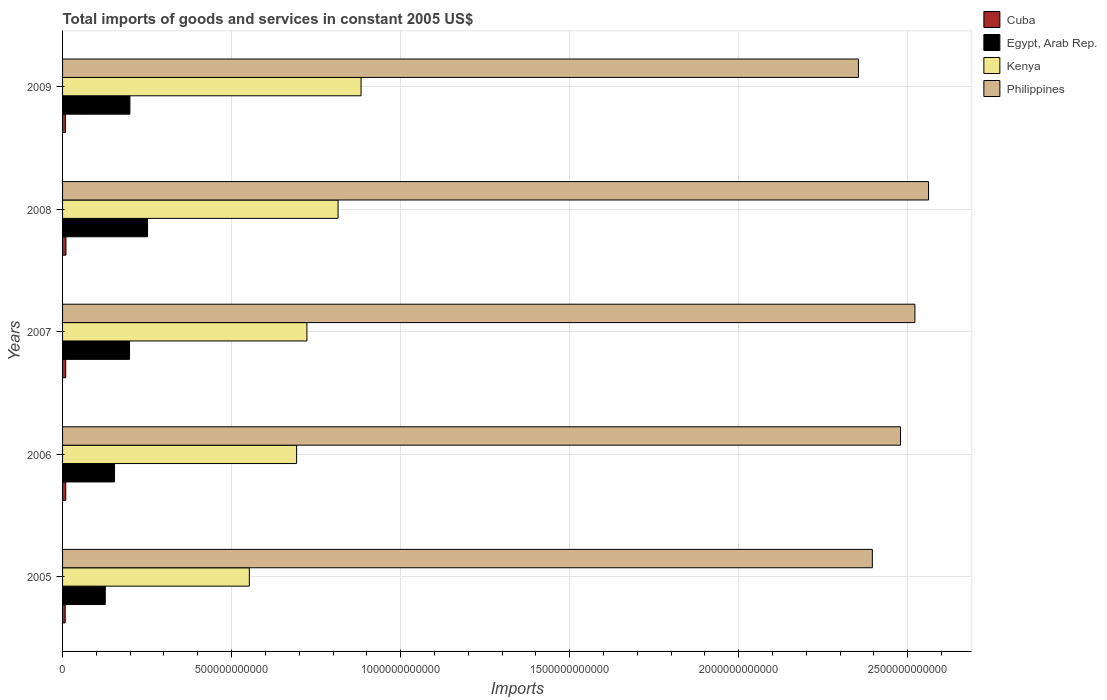How many groups of bars are there?
Keep it short and to the point. 5. Are the number of bars per tick equal to the number of legend labels?
Offer a terse response. Yes. How many bars are there on the 4th tick from the top?
Give a very brief answer. 4. What is the total imports of goods and services in Kenya in 2008?
Keep it short and to the point. 8.15e+11. Across all years, what is the maximum total imports of goods and services in Cuba?
Provide a succinct answer. 1.00e+1. Across all years, what is the minimum total imports of goods and services in Egypt, Arab Rep.?
Your answer should be compact. 1.26e+11. In which year was the total imports of goods and services in Philippines maximum?
Make the answer very short. 2008. In which year was the total imports of goods and services in Cuba minimum?
Provide a short and direct response. 2005. What is the total total imports of goods and services in Philippines in the graph?
Your answer should be compact. 1.23e+13. What is the difference between the total imports of goods and services in Kenya in 2005 and that in 2007?
Offer a very short reply. -1.70e+11. What is the difference between the total imports of goods and services in Kenya in 2009 and the total imports of goods and services in Egypt, Arab Rep. in 2008?
Provide a succinct answer. 6.32e+11. What is the average total imports of goods and services in Kenya per year?
Your answer should be compact. 7.33e+11. In the year 2005, what is the difference between the total imports of goods and services in Egypt, Arab Rep. and total imports of goods and services in Kenya?
Keep it short and to the point. -4.26e+11. What is the ratio of the total imports of goods and services in Kenya in 2008 to that in 2009?
Give a very brief answer. 0.92. Is the difference between the total imports of goods and services in Egypt, Arab Rep. in 2006 and 2008 greater than the difference between the total imports of goods and services in Kenya in 2006 and 2008?
Keep it short and to the point. Yes. What is the difference between the highest and the second highest total imports of goods and services in Cuba?
Offer a very short reply. 5.83e+08. What is the difference between the highest and the lowest total imports of goods and services in Cuba?
Your answer should be very brief. 2.18e+09. What does the 3rd bar from the top in 2007 represents?
Keep it short and to the point. Egypt, Arab Rep. What does the 2nd bar from the bottom in 2009 represents?
Offer a terse response. Egypt, Arab Rep. Is it the case that in every year, the sum of the total imports of goods and services in Philippines and total imports of goods and services in Egypt, Arab Rep. is greater than the total imports of goods and services in Kenya?
Offer a very short reply. Yes. What is the difference between two consecutive major ticks on the X-axis?
Provide a short and direct response. 5.00e+11. Does the graph contain any zero values?
Provide a succinct answer. No. Does the graph contain grids?
Your answer should be compact. Yes. Where does the legend appear in the graph?
Give a very brief answer. Top right. How are the legend labels stacked?
Your response must be concise. Vertical. What is the title of the graph?
Give a very brief answer. Total imports of goods and services in constant 2005 US$. What is the label or title of the X-axis?
Offer a terse response. Imports. What is the label or title of the Y-axis?
Offer a terse response. Years. What is the Imports in Cuba in 2005?
Your response must be concise. 7.82e+09. What is the Imports of Egypt, Arab Rep. in 2005?
Make the answer very short. 1.26e+11. What is the Imports in Kenya in 2005?
Keep it short and to the point. 5.52e+11. What is the Imports of Philippines in 2005?
Make the answer very short. 2.40e+12. What is the Imports of Cuba in 2006?
Provide a short and direct response. 9.42e+09. What is the Imports of Egypt, Arab Rep. in 2006?
Offer a very short reply. 1.54e+11. What is the Imports of Kenya in 2006?
Give a very brief answer. 6.92e+11. What is the Imports in Philippines in 2006?
Provide a succinct answer. 2.48e+12. What is the Imports in Cuba in 2007?
Your answer should be compact. 9.32e+09. What is the Imports in Egypt, Arab Rep. in 2007?
Provide a short and direct response. 1.98e+11. What is the Imports of Kenya in 2007?
Provide a succinct answer. 7.23e+11. What is the Imports in Philippines in 2007?
Your answer should be very brief. 2.52e+12. What is the Imports in Cuba in 2008?
Offer a very short reply. 1.00e+1. What is the Imports of Egypt, Arab Rep. in 2008?
Ensure brevity in your answer.  2.51e+11. What is the Imports in Kenya in 2008?
Offer a terse response. 8.15e+11. What is the Imports of Philippines in 2008?
Your answer should be very brief. 2.56e+12. What is the Imports in Cuba in 2009?
Keep it short and to the point. 8.51e+09. What is the Imports of Egypt, Arab Rep. in 2009?
Give a very brief answer. 1.99e+11. What is the Imports of Kenya in 2009?
Keep it short and to the point. 8.83e+11. What is the Imports of Philippines in 2009?
Keep it short and to the point. 2.35e+12. Across all years, what is the maximum Imports of Cuba?
Offer a very short reply. 1.00e+1. Across all years, what is the maximum Imports in Egypt, Arab Rep.?
Your answer should be very brief. 2.51e+11. Across all years, what is the maximum Imports in Kenya?
Provide a succinct answer. 8.83e+11. Across all years, what is the maximum Imports in Philippines?
Your answer should be compact. 2.56e+12. Across all years, what is the minimum Imports in Cuba?
Your answer should be compact. 7.82e+09. Across all years, what is the minimum Imports in Egypt, Arab Rep.?
Keep it short and to the point. 1.26e+11. Across all years, what is the minimum Imports of Kenya?
Ensure brevity in your answer.  5.52e+11. Across all years, what is the minimum Imports in Philippines?
Provide a short and direct response. 2.35e+12. What is the total Imports in Cuba in the graph?
Your answer should be very brief. 4.51e+1. What is the total Imports in Egypt, Arab Rep. in the graph?
Give a very brief answer. 9.29e+11. What is the total Imports in Kenya in the graph?
Provide a short and direct response. 3.67e+12. What is the total Imports in Philippines in the graph?
Provide a succinct answer. 1.23e+13. What is the difference between the Imports in Cuba in 2005 and that in 2006?
Keep it short and to the point. -1.60e+09. What is the difference between the Imports of Egypt, Arab Rep. in 2005 and that in 2006?
Offer a very short reply. -2.75e+1. What is the difference between the Imports of Kenya in 2005 and that in 2006?
Keep it short and to the point. -1.40e+11. What is the difference between the Imports in Philippines in 2005 and that in 2006?
Ensure brevity in your answer.  -8.32e+1. What is the difference between the Imports of Cuba in 2005 and that in 2007?
Provide a short and direct response. -1.49e+09. What is the difference between the Imports in Egypt, Arab Rep. in 2005 and that in 2007?
Offer a very short reply. -7.18e+1. What is the difference between the Imports of Kenya in 2005 and that in 2007?
Give a very brief answer. -1.70e+11. What is the difference between the Imports in Philippines in 2005 and that in 2007?
Provide a succinct answer. -1.26e+11. What is the difference between the Imports in Cuba in 2005 and that in 2008?
Your response must be concise. -2.18e+09. What is the difference between the Imports in Egypt, Arab Rep. in 2005 and that in 2008?
Offer a very short reply. -1.25e+11. What is the difference between the Imports in Kenya in 2005 and that in 2008?
Provide a short and direct response. -2.62e+11. What is the difference between the Imports in Philippines in 2005 and that in 2008?
Your answer should be compact. -1.66e+11. What is the difference between the Imports in Cuba in 2005 and that in 2009?
Give a very brief answer. -6.87e+08. What is the difference between the Imports in Egypt, Arab Rep. in 2005 and that in 2009?
Make the answer very short. -7.29e+1. What is the difference between the Imports of Kenya in 2005 and that in 2009?
Ensure brevity in your answer.  -3.30e+11. What is the difference between the Imports in Philippines in 2005 and that in 2009?
Keep it short and to the point. 4.11e+1. What is the difference between the Imports in Cuba in 2006 and that in 2007?
Ensure brevity in your answer.  1.04e+08. What is the difference between the Imports in Egypt, Arab Rep. in 2006 and that in 2007?
Your answer should be compact. -4.43e+1. What is the difference between the Imports of Kenya in 2006 and that in 2007?
Your answer should be compact. -3.05e+1. What is the difference between the Imports of Philippines in 2006 and that in 2007?
Provide a short and direct response. -4.27e+1. What is the difference between the Imports in Cuba in 2006 and that in 2008?
Your response must be concise. -5.83e+08. What is the difference between the Imports of Egypt, Arab Rep. in 2006 and that in 2008?
Your response must be concise. -9.76e+1. What is the difference between the Imports of Kenya in 2006 and that in 2008?
Give a very brief answer. -1.23e+11. What is the difference between the Imports in Philippines in 2006 and that in 2008?
Offer a very short reply. -8.30e+1. What is the difference between the Imports of Cuba in 2006 and that in 2009?
Your answer should be very brief. 9.12e+08. What is the difference between the Imports of Egypt, Arab Rep. in 2006 and that in 2009?
Your answer should be very brief. -4.54e+1. What is the difference between the Imports in Kenya in 2006 and that in 2009?
Ensure brevity in your answer.  -1.91e+11. What is the difference between the Imports of Philippines in 2006 and that in 2009?
Ensure brevity in your answer.  1.24e+11. What is the difference between the Imports of Cuba in 2007 and that in 2008?
Offer a very short reply. -6.87e+08. What is the difference between the Imports of Egypt, Arab Rep. in 2007 and that in 2008?
Give a very brief answer. -5.33e+1. What is the difference between the Imports in Kenya in 2007 and that in 2008?
Your response must be concise. -9.21e+1. What is the difference between the Imports in Philippines in 2007 and that in 2008?
Your answer should be compact. -4.03e+1. What is the difference between the Imports of Cuba in 2007 and that in 2009?
Offer a very short reply. 8.08e+08. What is the difference between the Imports in Egypt, Arab Rep. in 2007 and that in 2009?
Offer a terse response. -1.10e+09. What is the difference between the Imports of Kenya in 2007 and that in 2009?
Provide a short and direct response. -1.60e+11. What is the difference between the Imports in Philippines in 2007 and that in 2009?
Your answer should be very brief. 1.67e+11. What is the difference between the Imports of Cuba in 2008 and that in 2009?
Give a very brief answer. 1.49e+09. What is the difference between the Imports of Egypt, Arab Rep. in 2008 and that in 2009?
Make the answer very short. 5.22e+1. What is the difference between the Imports in Kenya in 2008 and that in 2009?
Make the answer very short. -6.80e+1. What is the difference between the Imports of Philippines in 2008 and that in 2009?
Provide a succinct answer. 2.07e+11. What is the difference between the Imports of Cuba in 2005 and the Imports of Egypt, Arab Rep. in 2006?
Give a very brief answer. -1.46e+11. What is the difference between the Imports in Cuba in 2005 and the Imports in Kenya in 2006?
Offer a very short reply. -6.84e+11. What is the difference between the Imports in Cuba in 2005 and the Imports in Philippines in 2006?
Your answer should be very brief. -2.47e+12. What is the difference between the Imports of Egypt, Arab Rep. in 2005 and the Imports of Kenya in 2006?
Provide a short and direct response. -5.66e+11. What is the difference between the Imports of Egypt, Arab Rep. in 2005 and the Imports of Philippines in 2006?
Your answer should be compact. -2.35e+12. What is the difference between the Imports in Kenya in 2005 and the Imports in Philippines in 2006?
Make the answer very short. -1.93e+12. What is the difference between the Imports in Cuba in 2005 and the Imports in Egypt, Arab Rep. in 2007?
Your answer should be very brief. -1.90e+11. What is the difference between the Imports in Cuba in 2005 and the Imports in Kenya in 2007?
Give a very brief answer. -7.15e+11. What is the difference between the Imports of Cuba in 2005 and the Imports of Philippines in 2007?
Make the answer very short. -2.51e+12. What is the difference between the Imports in Egypt, Arab Rep. in 2005 and the Imports in Kenya in 2007?
Your answer should be very brief. -5.96e+11. What is the difference between the Imports of Egypt, Arab Rep. in 2005 and the Imports of Philippines in 2007?
Your response must be concise. -2.39e+12. What is the difference between the Imports of Kenya in 2005 and the Imports of Philippines in 2007?
Give a very brief answer. -1.97e+12. What is the difference between the Imports of Cuba in 2005 and the Imports of Egypt, Arab Rep. in 2008?
Provide a succinct answer. -2.44e+11. What is the difference between the Imports of Cuba in 2005 and the Imports of Kenya in 2008?
Offer a terse response. -8.07e+11. What is the difference between the Imports in Cuba in 2005 and the Imports in Philippines in 2008?
Make the answer very short. -2.55e+12. What is the difference between the Imports of Egypt, Arab Rep. in 2005 and the Imports of Kenya in 2008?
Your response must be concise. -6.89e+11. What is the difference between the Imports in Egypt, Arab Rep. in 2005 and the Imports in Philippines in 2008?
Provide a succinct answer. -2.44e+12. What is the difference between the Imports of Kenya in 2005 and the Imports of Philippines in 2008?
Provide a succinct answer. -2.01e+12. What is the difference between the Imports in Cuba in 2005 and the Imports in Egypt, Arab Rep. in 2009?
Your answer should be compact. -1.91e+11. What is the difference between the Imports of Cuba in 2005 and the Imports of Kenya in 2009?
Your answer should be compact. -8.75e+11. What is the difference between the Imports in Cuba in 2005 and the Imports in Philippines in 2009?
Your answer should be compact. -2.35e+12. What is the difference between the Imports of Egypt, Arab Rep. in 2005 and the Imports of Kenya in 2009?
Your response must be concise. -7.57e+11. What is the difference between the Imports of Egypt, Arab Rep. in 2005 and the Imports of Philippines in 2009?
Your response must be concise. -2.23e+12. What is the difference between the Imports of Kenya in 2005 and the Imports of Philippines in 2009?
Provide a succinct answer. -1.80e+12. What is the difference between the Imports of Cuba in 2006 and the Imports of Egypt, Arab Rep. in 2007?
Ensure brevity in your answer.  -1.89e+11. What is the difference between the Imports in Cuba in 2006 and the Imports in Kenya in 2007?
Your answer should be very brief. -7.13e+11. What is the difference between the Imports in Cuba in 2006 and the Imports in Philippines in 2007?
Your answer should be compact. -2.51e+12. What is the difference between the Imports in Egypt, Arab Rep. in 2006 and the Imports in Kenya in 2007?
Make the answer very short. -5.69e+11. What is the difference between the Imports of Egypt, Arab Rep. in 2006 and the Imports of Philippines in 2007?
Offer a terse response. -2.37e+12. What is the difference between the Imports in Kenya in 2006 and the Imports in Philippines in 2007?
Ensure brevity in your answer.  -1.83e+12. What is the difference between the Imports in Cuba in 2006 and the Imports in Egypt, Arab Rep. in 2008?
Your answer should be compact. -2.42e+11. What is the difference between the Imports in Cuba in 2006 and the Imports in Kenya in 2008?
Keep it short and to the point. -8.05e+11. What is the difference between the Imports of Cuba in 2006 and the Imports of Philippines in 2008?
Provide a succinct answer. -2.55e+12. What is the difference between the Imports in Egypt, Arab Rep. in 2006 and the Imports in Kenya in 2008?
Give a very brief answer. -6.61e+11. What is the difference between the Imports of Egypt, Arab Rep. in 2006 and the Imports of Philippines in 2008?
Make the answer very short. -2.41e+12. What is the difference between the Imports in Kenya in 2006 and the Imports in Philippines in 2008?
Offer a very short reply. -1.87e+12. What is the difference between the Imports in Cuba in 2006 and the Imports in Egypt, Arab Rep. in 2009?
Your answer should be very brief. -1.90e+11. What is the difference between the Imports of Cuba in 2006 and the Imports of Kenya in 2009?
Provide a succinct answer. -8.73e+11. What is the difference between the Imports of Cuba in 2006 and the Imports of Philippines in 2009?
Keep it short and to the point. -2.34e+12. What is the difference between the Imports of Egypt, Arab Rep. in 2006 and the Imports of Kenya in 2009?
Provide a short and direct response. -7.29e+11. What is the difference between the Imports of Egypt, Arab Rep. in 2006 and the Imports of Philippines in 2009?
Offer a very short reply. -2.20e+12. What is the difference between the Imports in Kenya in 2006 and the Imports in Philippines in 2009?
Provide a short and direct response. -1.66e+12. What is the difference between the Imports of Cuba in 2007 and the Imports of Egypt, Arab Rep. in 2008?
Your response must be concise. -2.42e+11. What is the difference between the Imports of Cuba in 2007 and the Imports of Kenya in 2008?
Keep it short and to the point. -8.06e+11. What is the difference between the Imports of Cuba in 2007 and the Imports of Philippines in 2008?
Your answer should be compact. -2.55e+12. What is the difference between the Imports in Egypt, Arab Rep. in 2007 and the Imports in Kenya in 2008?
Keep it short and to the point. -6.17e+11. What is the difference between the Imports in Egypt, Arab Rep. in 2007 and the Imports in Philippines in 2008?
Make the answer very short. -2.36e+12. What is the difference between the Imports in Kenya in 2007 and the Imports in Philippines in 2008?
Make the answer very short. -1.84e+12. What is the difference between the Imports of Cuba in 2007 and the Imports of Egypt, Arab Rep. in 2009?
Offer a terse response. -1.90e+11. What is the difference between the Imports of Cuba in 2007 and the Imports of Kenya in 2009?
Keep it short and to the point. -8.74e+11. What is the difference between the Imports of Cuba in 2007 and the Imports of Philippines in 2009?
Keep it short and to the point. -2.34e+12. What is the difference between the Imports in Egypt, Arab Rep. in 2007 and the Imports in Kenya in 2009?
Give a very brief answer. -6.85e+11. What is the difference between the Imports of Egypt, Arab Rep. in 2007 and the Imports of Philippines in 2009?
Offer a terse response. -2.16e+12. What is the difference between the Imports in Kenya in 2007 and the Imports in Philippines in 2009?
Give a very brief answer. -1.63e+12. What is the difference between the Imports of Cuba in 2008 and the Imports of Egypt, Arab Rep. in 2009?
Keep it short and to the point. -1.89e+11. What is the difference between the Imports in Cuba in 2008 and the Imports in Kenya in 2009?
Make the answer very short. -8.73e+11. What is the difference between the Imports of Cuba in 2008 and the Imports of Philippines in 2009?
Your response must be concise. -2.34e+12. What is the difference between the Imports of Egypt, Arab Rep. in 2008 and the Imports of Kenya in 2009?
Offer a terse response. -6.32e+11. What is the difference between the Imports in Egypt, Arab Rep. in 2008 and the Imports in Philippines in 2009?
Your response must be concise. -2.10e+12. What is the difference between the Imports in Kenya in 2008 and the Imports in Philippines in 2009?
Provide a succinct answer. -1.54e+12. What is the average Imports of Cuba per year?
Ensure brevity in your answer.  9.01e+09. What is the average Imports in Egypt, Arab Rep. per year?
Give a very brief answer. 1.86e+11. What is the average Imports of Kenya per year?
Your answer should be very brief. 7.33e+11. What is the average Imports in Philippines per year?
Your answer should be very brief. 2.46e+12. In the year 2005, what is the difference between the Imports in Cuba and Imports in Egypt, Arab Rep.?
Provide a short and direct response. -1.18e+11. In the year 2005, what is the difference between the Imports in Cuba and Imports in Kenya?
Make the answer very short. -5.45e+11. In the year 2005, what is the difference between the Imports of Cuba and Imports of Philippines?
Provide a short and direct response. -2.39e+12. In the year 2005, what is the difference between the Imports of Egypt, Arab Rep. and Imports of Kenya?
Keep it short and to the point. -4.26e+11. In the year 2005, what is the difference between the Imports in Egypt, Arab Rep. and Imports in Philippines?
Your answer should be compact. -2.27e+12. In the year 2005, what is the difference between the Imports of Kenya and Imports of Philippines?
Make the answer very short. -1.84e+12. In the year 2006, what is the difference between the Imports of Cuba and Imports of Egypt, Arab Rep.?
Ensure brevity in your answer.  -1.44e+11. In the year 2006, what is the difference between the Imports in Cuba and Imports in Kenya?
Provide a succinct answer. -6.83e+11. In the year 2006, what is the difference between the Imports in Cuba and Imports in Philippines?
Your answer should be compact. -2.47e+12. In the year 2006, what is the difference between the Imports of Egypt, Arab Rep. and Imports of Kenya?
Offer a terse response. -5.38e+11. In the year 2006, what is the difference between the Imports in Egypt, Arab Rep. and Imports in Philippines?
Provide a succinct answer. -2.32e+12. In the year 2006, what is the difference between the Imports in Kenya and Imports in Philippines?
Offer a terse response. -1.79e+12. In the year 2007, what is the difference between the Imports of Cuba and Imports of Egypt, Arab Rep.?
Keep it short and to the point. -1.89e+11. In the year 2007, what is the difference between the Imports in Cuba and Imports in Kenya?
Give a very brief answer. -7.13e+11. In the year 2007, what is the difference between the Imports in Cuba and Imports in Philippines?
Make the answer very short. -2.51e+12. In the year 2007, what is the difference between the Imports of Egypt, Arab Rep. and Imports of Kenya?
Make the answer very short. -5.25e+11. In the year 2007, what is the difference between the Imports in Egypt, Arab Rep. and Imports in Philippines?
Your response must be concise. -2.32e+12. In the year 2007, what is the difference between the Imports in Kenya and Imports in Philippines?
Your response must be concise. -1.80e+12. In the year 2008, what is the difference between the Imports of Cuba and Imports of Egypt, Arab Rep.?
Offer a terse response. -2.41e+11. In the year 2008, what is the difference between the Imports in Cuba and Imports in Kenya?
Keep it short and to the point. -8.05e+11. In the year 2008, what is the difference between the Imports of Cuba and Imports of Philippines?
Your answer should be very brief. -2.55e+12. In the year 2008, what is the difference between the Imports in Egypt, Arab Rep. and Imports in Kenya?
Offer a terse response. -5.64e+11. In the year 2008, what is the difference between the Imports of Egypt, Arab Rep. and Imports of Philippines?
Offer a terse response. -2.31e+12. In the year 2008, what is the difference between the Imports of Kenya and Imports of Philippines?
Make the answer very short. -1.75e+12. In the year 2009, what is the difference between the Imports in Cuba and Imports in Egypt, Arab Rep.?
Provide a succinct answer. -1.91e+11. In the year 2009, what is the difference between the Imports of Cuba and Imports of Kenya?
Make the answer very short. -8.74e+11. In the year 2009, what is the difference between the Imports in Cuba and Imports in Philippines?
Offer a very short reply. -2.35e+12. In the year 2009, what is the difference between the Imports of Egypt, Arab Rep. and Imports of Kenya?
Offer a very short reply. -6.84e+11. In the year 2009, what is the difference between the Imports in Egypt, Arab Rep. and Imports in Philippines?
Your answer should be very brief. -2.15e+12. In the year 2009, what is the difference between the Imports in Kenya and Imports in Philippines?
Your answer should be compact. -1.47e+12. What is the ratio of the Imports in Cuba in 2005 to that in 2006?
Ensure brevity in your answer.  0.83. What is the ratio of the Imports of Egypt, Arab Rep. in 2005 to that in 2006?
Provide a succinct answer. 0.82. What is the ratio of the Imports of Kenya in 2005 to that in 2006?
Your response must be concise. 0.8. What is the ratio of the Imports in Philippines in 2005 to that in 2006?
Ensure brevity in your answer.  0.97. What is the ratio of the Imports in Cuba in 2005 to that in 2007?
Provide a succinct answer. 0.84. What is the ratio of the Imports of Egypt, Arab Rep. in 2005 to that in 2007?
Make the answer very short. 0.64. What is the ratio of the Imports of Kenya in 2005 to that in 2007?
Your answer should be very brief. 0.76. What is the ratio of the Imports in Philippines in 2005 to that in 2007?
Make the answer very short. 0.95. What is the ratio of the Imports in Cuba in 2005 to that in 2008?
Your response must be concise. 0.78. What is the ratio of the Imports of Egypt, Arab Rep. in 2005 to that in 2008?
Offer a terse response. 0.5. What is the ratio of the Imports in Kenya in 2005 to that in 2008?
Your answer should be very brief. 0.68. What is the ratio of the Imports in Philippines in 2005 to that in 2008?
Ensure brevity in your answer.  0.94. What is the ratio of the Imports in Cuba in 2005 to that in 2009?
Offer a terse response. 0.92. What is the ratio of the Imports in Egypt, Arab Rep. in 2005 to that in 2009?
Provide a succinct answer. 0.63. What is the ratio of the Imports in Kenya in 2005 to that in 2009?
Offer a terse response. 0.63. What is the ratio of the Imports in Philippines in 2005 to that in 2009?
Ensure brevity in your answer.  1.02. What is the ratio of the Imports in Cuba in 2006 to that in 2007?
Give a very brief answer. 1.01. What is the ratio of the Imports in Egypt, Arab Rep. in 2006 to that in 2007?
Provide a short and direct response. 0.78. What is the ratio of the Imports of Kenya in 2006 to that in 2007?
Your answer should be compact. 0.96. What is the ratio of the Imports of Philippines in 2006 to that in 2007?
Make the answer very short. 0.98. What is the ratio of the Imports of Cuba in 2006 to that in 2008?
Ensure brevity in your answer.  0.94. What is the ratio of the Imports of Egypt, Arab Rep. in 2006 to that in 2008?
Offer a very short reply. 0.61. What is the ratio of the Imports of Kenya in 2006 to that in 2008?
Offer a terse response. 0.85. What is the ratio of the Imports in Philippines in 2006 to that in 2008?
Give a very brief answer. 0.97. What is the ratio of the Imports in Cuba in 2006 to that in 2009?
Your answer should be compact. 1.11. What is the ratio of the Imports of Egypt, Arab Rep. in 2006 to that in 2009?
Your response must be concise. 0.77. What is the ratio of the Imports of Kenya in 2006 to that in 2009?
Offer a terse response. 0.78. What is the ratio of the Imports of Philippines in 2006 to that in 2009?
Keep it short and to the point. 1.05. What is the ratio of the Imports of Cuba in 2007 to that in 2008?
Your answer should be very brief. 0.93. What is the ratio of the Imports in Egypt, Arab Rep. in 2007 to that in 2008?
Your answer should be very brief. 0.79. What is the ratio of the Imports in Kenya in 2007 to that in 2008?
Offer a terse response. 0.89. What is the ratio of the Imports in Philippines in 2007 to that in 2008?
Your answer should be very brief. 0.98. What is the ratio of the Imports in Cuba in 2007 to that in 2009?
Keep it short and to the point. 1.09. What is the ratio of the Imports of Kenya in 2007 to that in 2009?
Your response must be concise. 0.82. What is the ratio of the Imports of Philippines in 2007 to that in 2009?
Your response must be concise. 1.07. What is the ratio of the Imports in Cuba in 2008 to that in 2009?
Your answer should be compact. 1.18. What is the ratio of the Imports in Egypt, Arab Rep. in 2008 to that in 2009?
Your response must be concise. 1.26. What is the ratio of the Imports in Kenya in 2008 to that in 2009?
Provide a short and direct response. 0.92. What is the ratio of the Imports in Philippines in 2008 to that in 2009?
Your response must be concise. 1.09. What is the difference between the highest and the second highest Imports of Cuba?
Offer a terse response. 5.83e+08. What is the difference between the highest and the second highest Imports in Egypt, Arab Rep.?
Offer a very short reply. 5.22e+1. What is the difference between the highest and the second highest Imports in Kenya?
Give a very brief answer. 6.80e+1. What is the difference between the highest and the second highest Imports in Philippines?
Provide a short and direct response. 4.03e+1. What is the difference between the highest and the lowest Imports of Cuba?
Keep it short and to the point. 2.18e+09. What is the difference between the highest and the lowest Imports in Egypt, Arab Rep.?
Keep it short and to the point. 1.25e+11. What is the difference between the highest and the lowest Imports in Kenya?
Your answer should be very brief. 3.30e+11. What is the difference between the highest and the lowest Imports of Philippines?
Provide a short and direct response. 2.07e+11. 